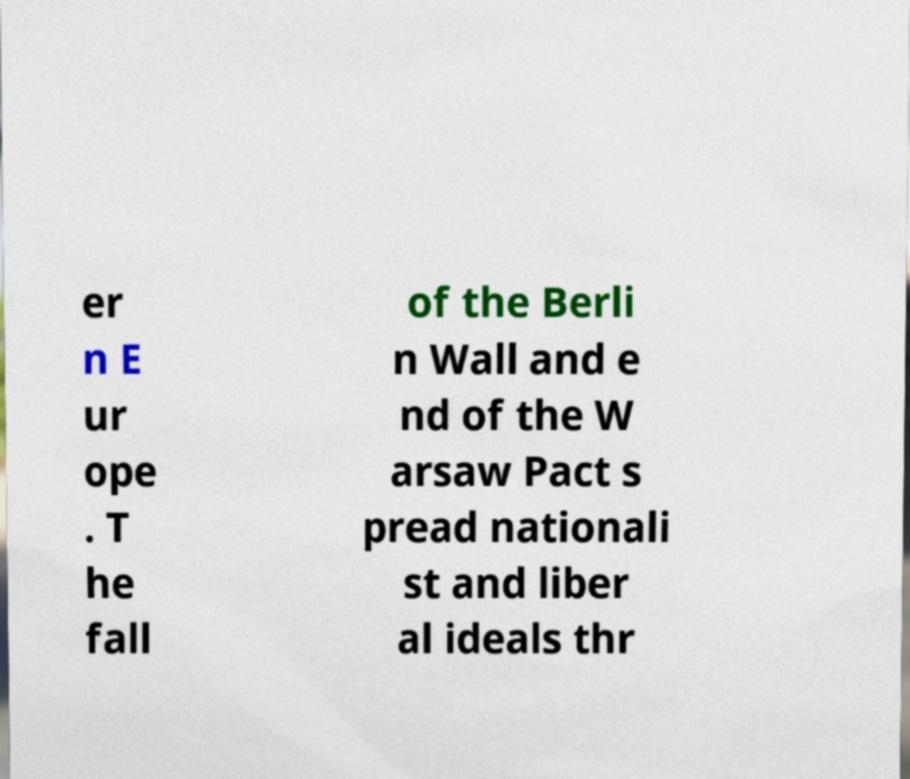Can you read and provide the text displayed in the image?This photo seems to have some interesting text. Can you extract and type it out for me? er n E ur ope . T he fall of the Berli n Wall and e nd of the W arsaw Pact s pread nationali st and liber al ideals thr 